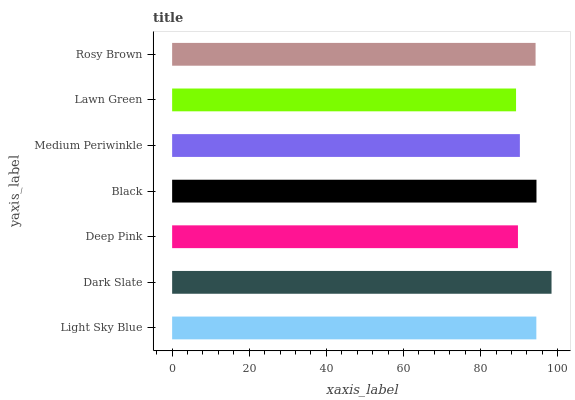Is Lawn Green the minimum?
Answer yes or no. Yes. Is Dark Slate the maximum?
Answer yes or no. Yes. Is Deep Pink the minimum?
Answer yes or no. No. Is Deep Pink the maximum?
Answer yes or no. No. Is Dark Slate greater than Deep Pink?
Answer yes or no. Yes. Is Deep Pink less than Dark Slate?
Answer yes or no. Yes. Is Deep Pink greater than Dark Slate?
Answer yes or no. No. Is Dark Slate less than Deep Pink?
Answer yes or no. No. Is Rosy Brown the high median?
Answer yes or no. Yes. Is Rosy Brown the low median?
Answer yes or no. Yes. Is Black the high median?
Answer yes or no. No. Is Deep Pink the low median?
Answer yes or no. No. 